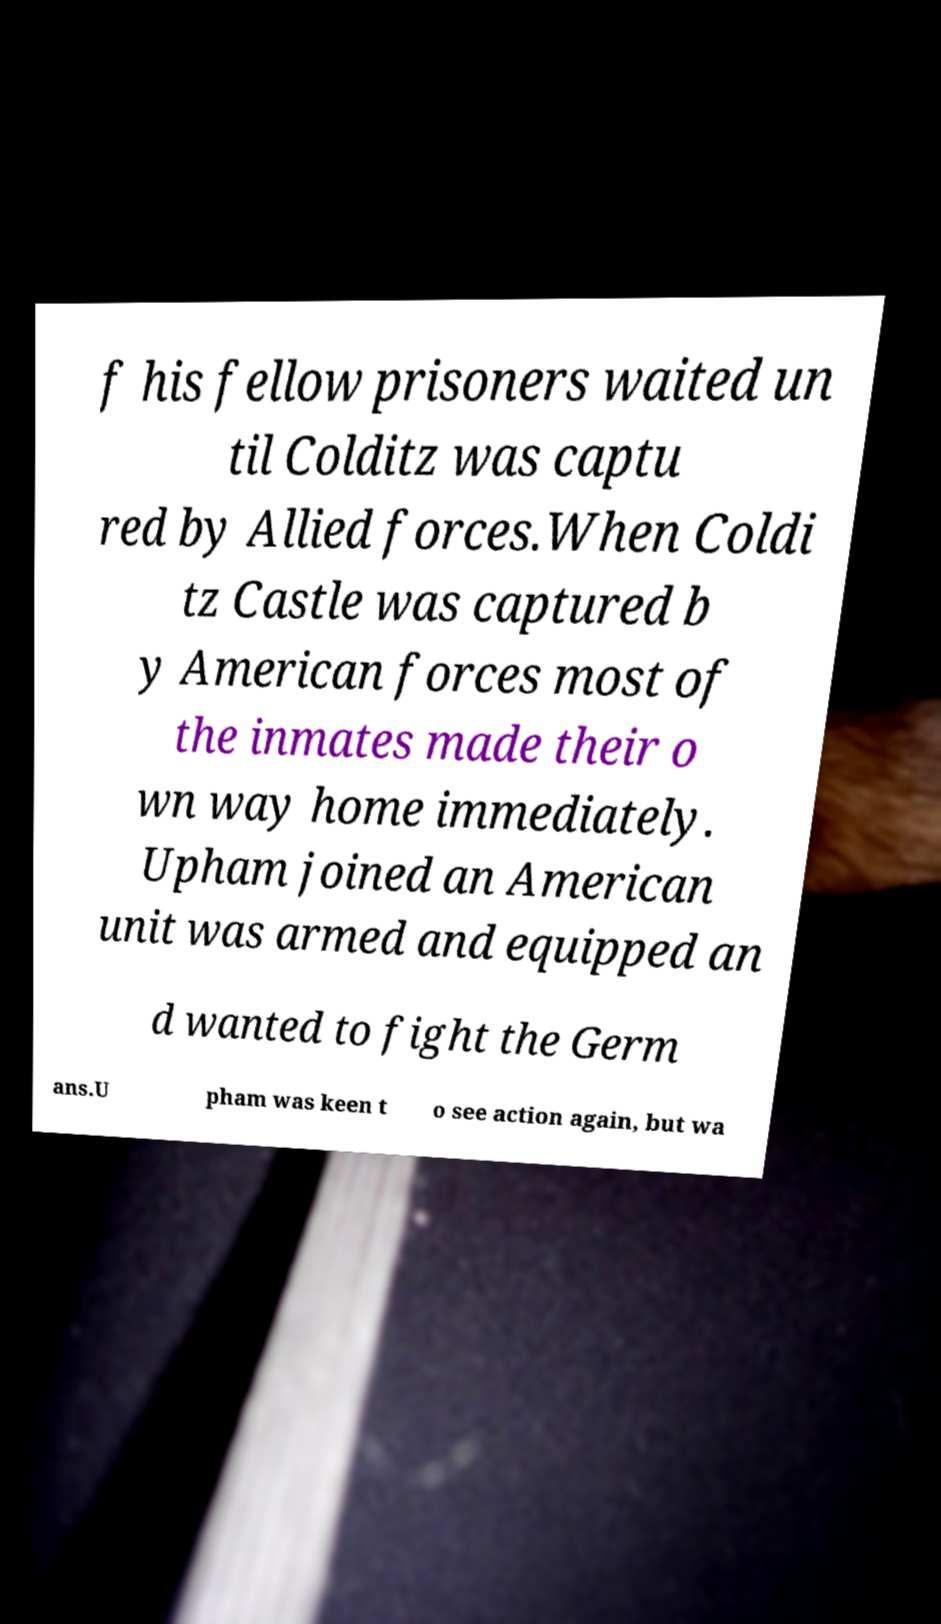There's text embedded in this image that I need extracted. Can you transcribe it verbatim? f his fellow prisoners waited un til Colditz was captu red by Allied forces.When Coldi tz Castle was captured b y American forces most of the inmates made their o wn way home immediately. Upham joined an American unit was armed and equipped an d wanted to fight the Germ ans.U pham was keen t o see action again, but wa 